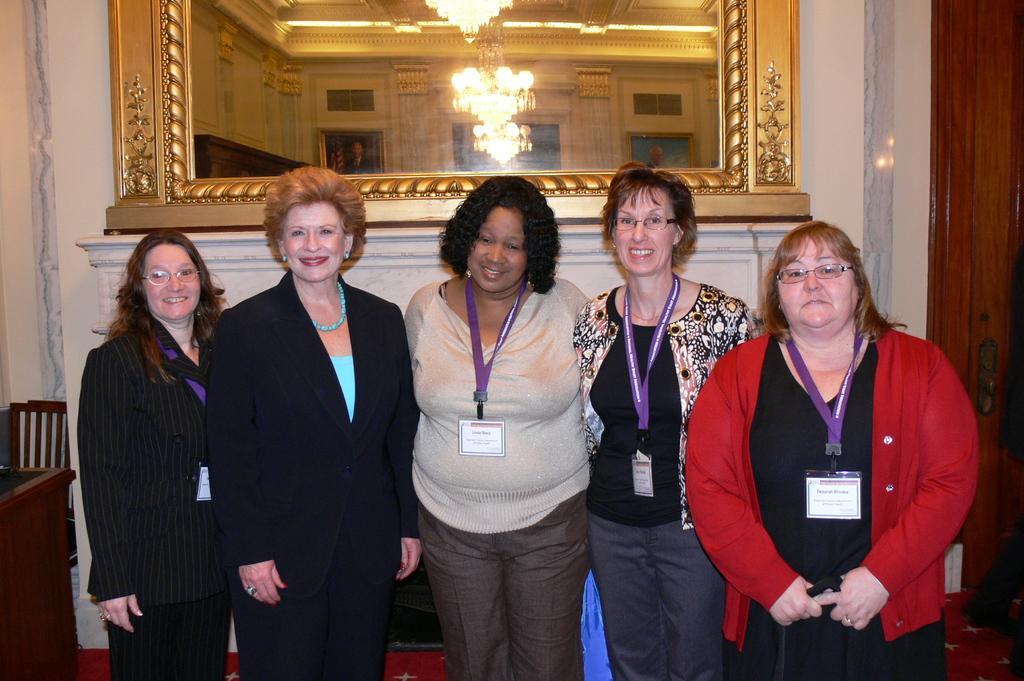Could you give a brief overview of what you see in this image? Here in this picture we can see a group of women standing over a place and we can see all of them are smiling and wearing ID cards on them and behind them on the wall we can see a mirror present and in that we can see chandeliers present on the roof and on the left side we can see a chair and a table present. 